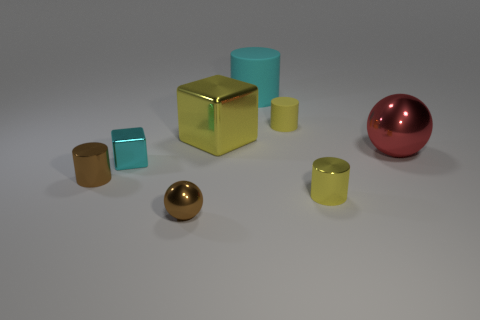Subtract all small cylinders. How many cylinders are left? 1 Subtract all purple cubes. How many yellow cylinders are left? 2 Subtract all brown cylinders. How many cylinders are left? 3 Add 1 tiny cubes. How many objects exist? 9 Subtract 1 cylinders. How many cylinders are left? 3 Subtract all balls. How many objects are left? 6 Subtract all red cylinders. Subtract all cyan blocks. How many cylinders are left? 4 Subtract all big red matte things. Subtract all metal blocks. How many objects are left? 6 Add 7 tiny brown metal cylinders. How many tiny brown metal cylinders are left? 8 Add 8 tiny metallic cubes. How many tiny metallic cubes exist? 9 